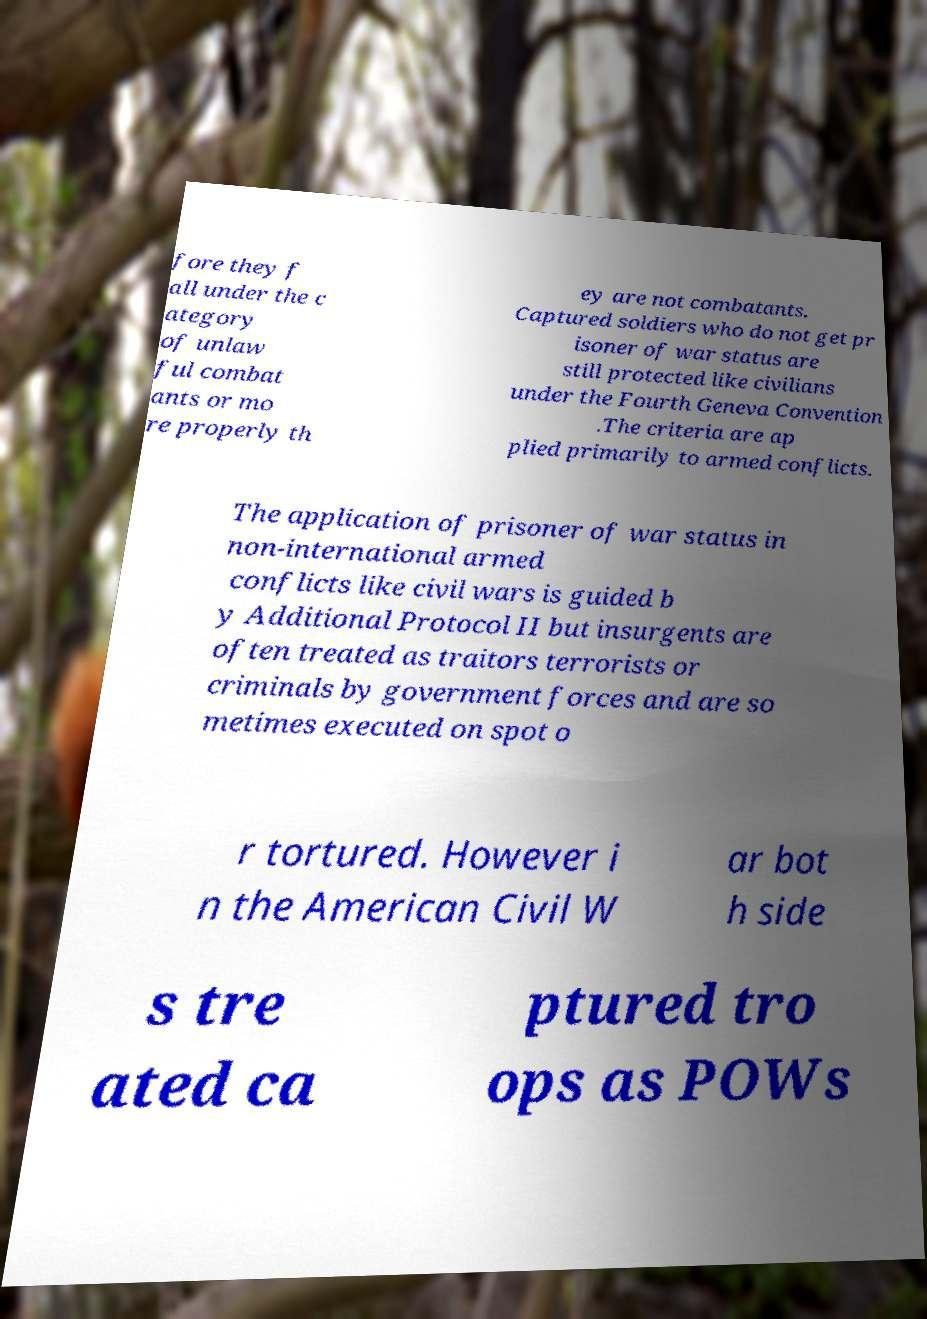Please identify and transcribe the text found in this image. fore they f all under the c ategory of unlaw ful combat ants or mo re properly th ey are not combatants. Captured soldiers who do not get pr isoner of war status are still protected like civilians under the Fourth Geneva Convention .The criteria are ap plied primarily to armed conflicts. The application of prisoner of war status in non-international armed conflicts like civil wars is guided b y Additional Protocol II but insurgents are often treated as traitors terrorists or criminals by government forces and are so metimes executed on spot o r tortured. However i n the American Civil W ar bot h side s tre ated ca ptured tro ops as POWs 